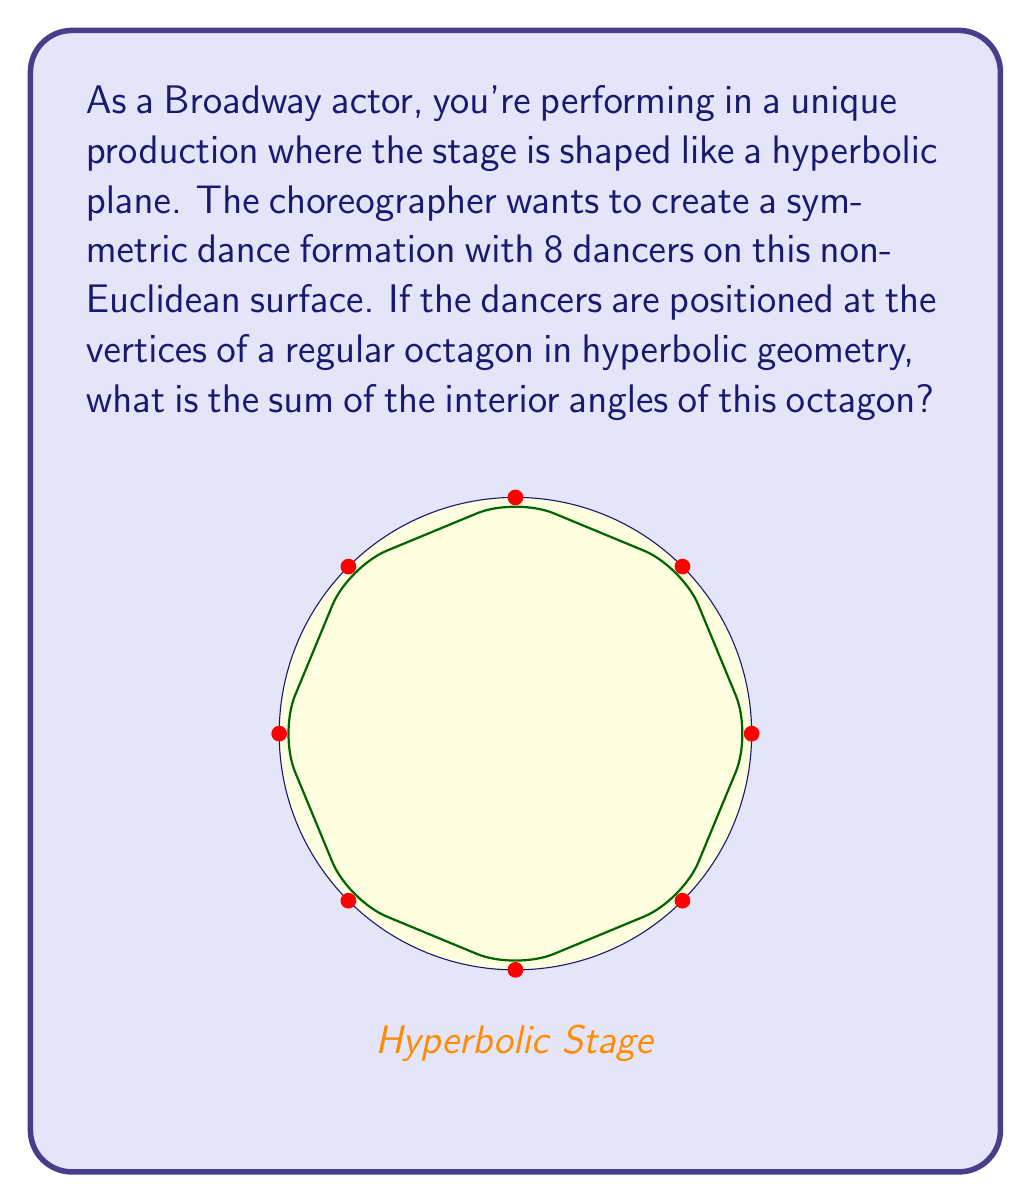Help me with this question. Let's approach this step-by-step:

1) In Euclidean geometry, the sum of interior angles of a regular octagon is always $6\pi$ radians or $1080°$. However, this doesn't hold true in hyperbolic geometry.

2) In hyperbolic geometry, the sum of the angles in a polygon is always less than what it would be in Euclidean geometry. This is due to the negative curvature of hyperbolic space.

3) For a hyperbolic n-gon, the sum of interior angles is given by the formula:

   $$ S = (n-2)\pi - A $$

   Where $S$ is the sum of angles, $n$ is the number of sides, and $A$ is the area of the polygon in hyperbolic units.

4) For our octagon, $n = 8$, so we have:

   $$ S = (8-2)\pi - A = 6\pi - A $$

5) The area $A$ depends on the specific size of the octagon in the hyperbolic plane. Without this information, we can't calculate an exact value for $S$.

6) However, we can conclude that:

   $$ S < 6\pi $$

   This is because $A$ is always positive in hyperbolic geometry.

7) We can also express this inequality in degrees:

   $$ S < 1080° $$

Thus, the sum of the interior angles of the hyperbolic octagon is less than $6\pi$ radians or $1080°$, but we can't determine the exact value without more information about the specific size of the octagon on the hyperbolic stage.
Answer: $S < 6\pi$ radians (or $S < 1080°$) 